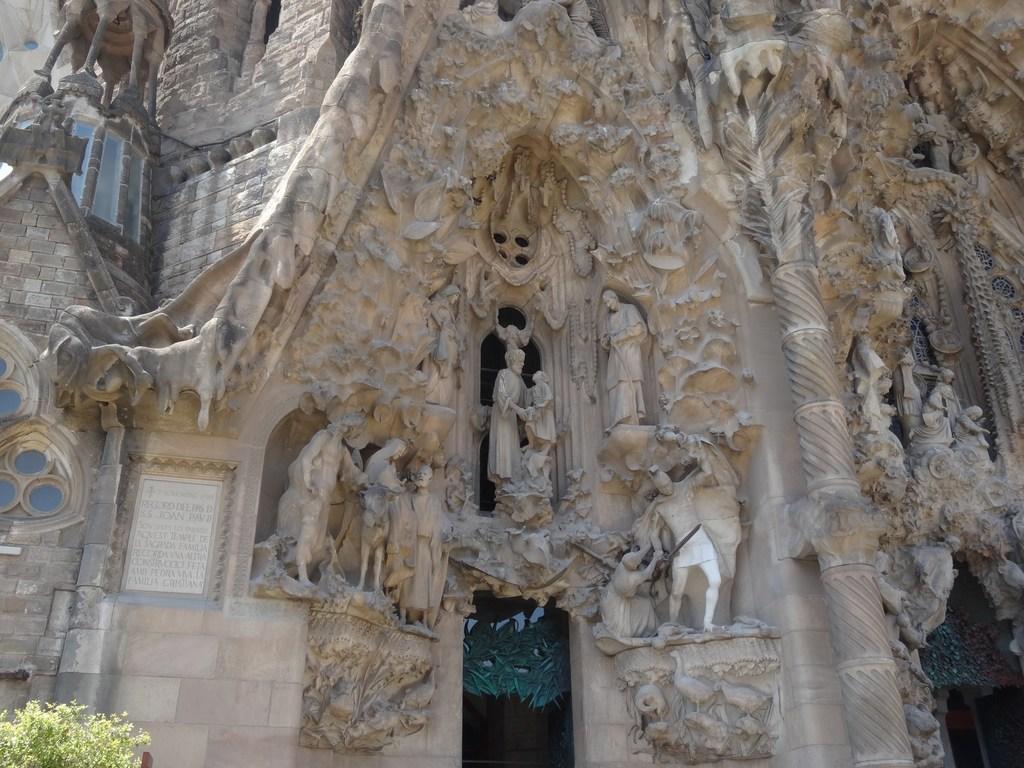How would you summarize this image in a sentence or two? In this image we can see the statues on the walls of the building. We can also see the text and also a plant. 